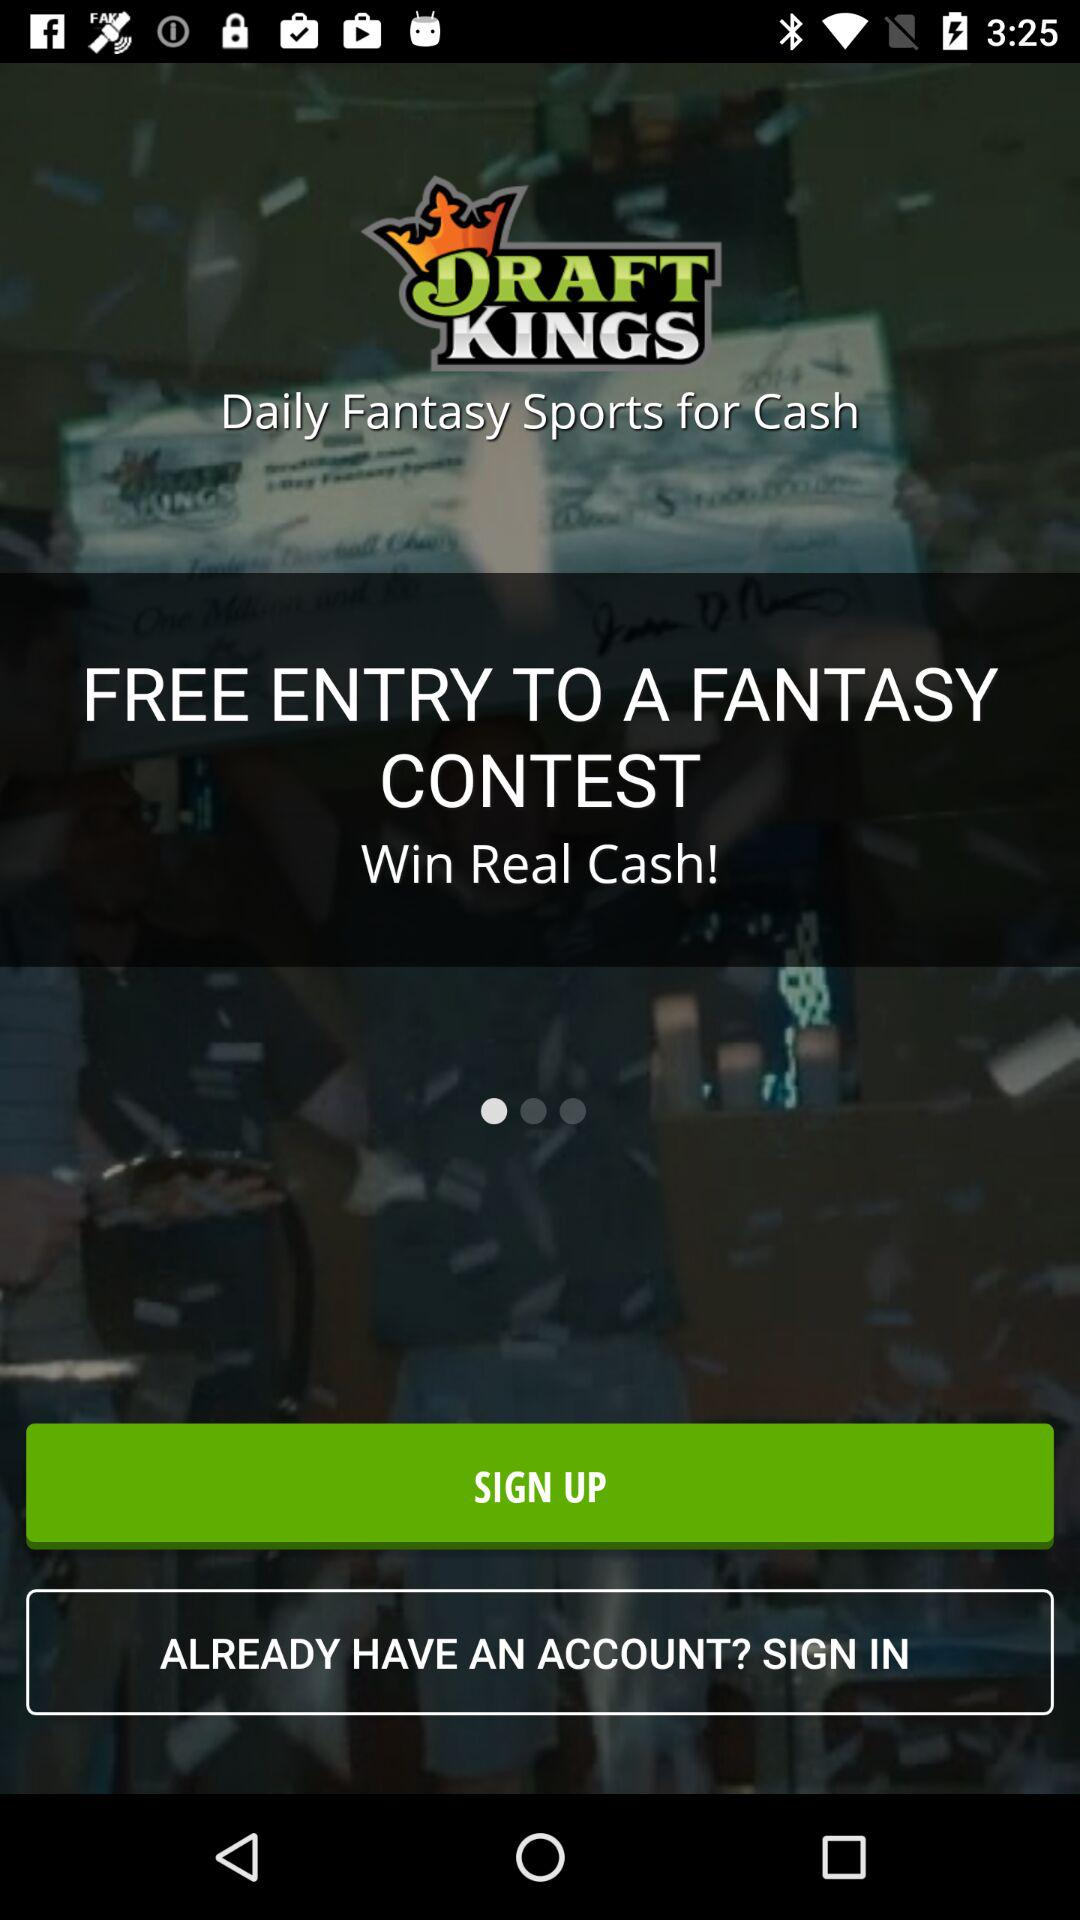What is the name of the application? The name of the application is "DRAFT KINGS". 